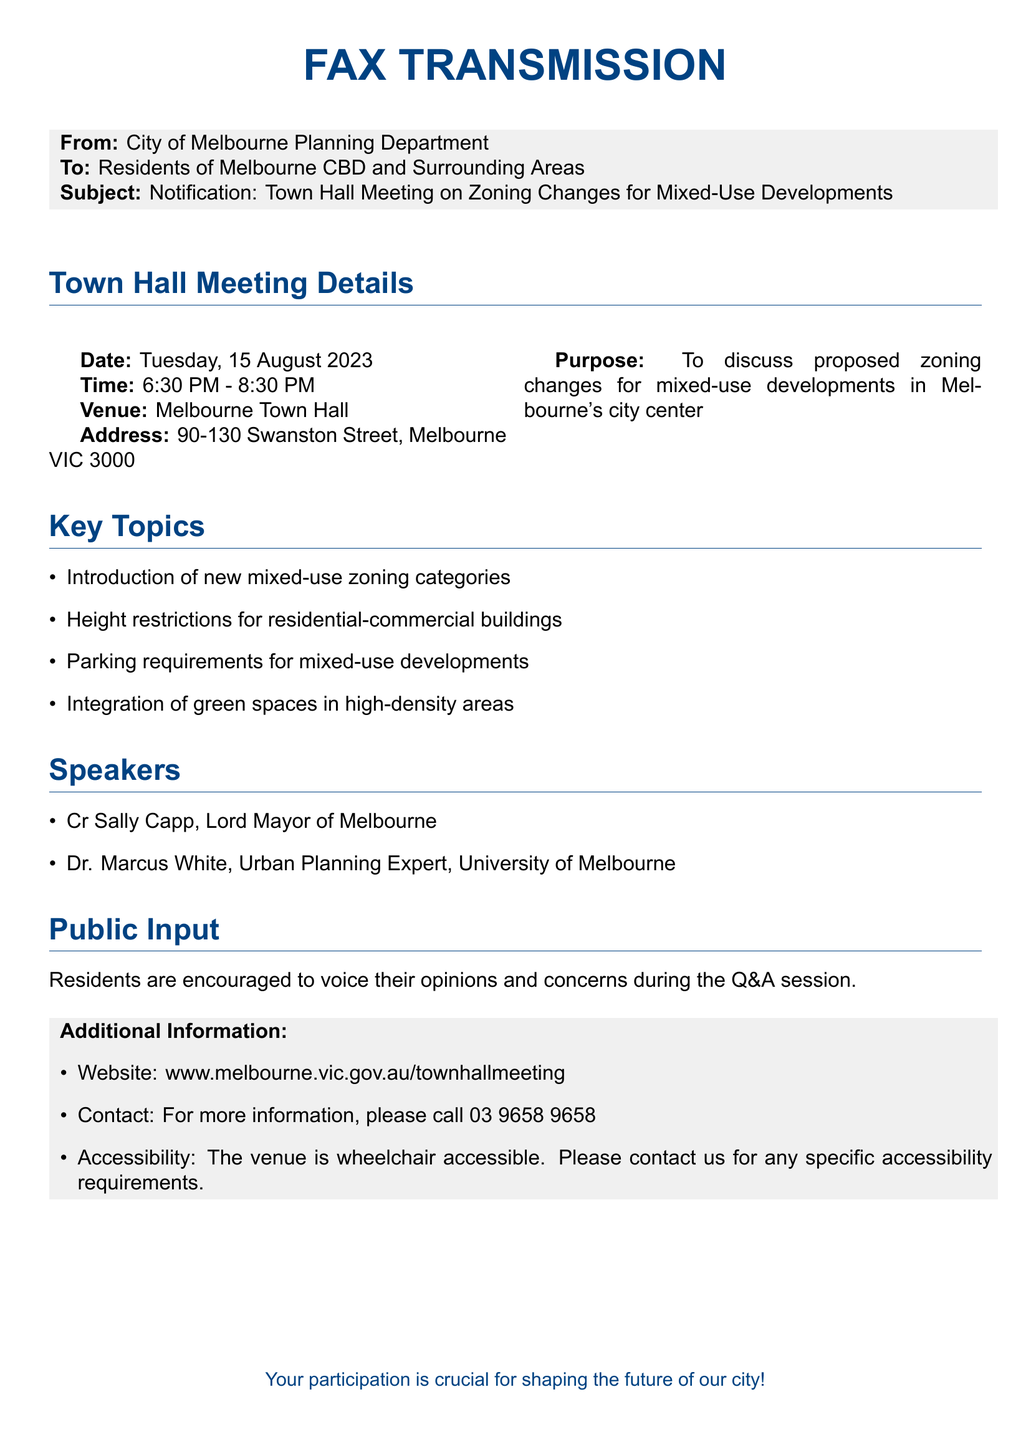what is the date of the town hall meeting? The date is explicitly stated in the meeting details section of the document.
Answer: Tuesday, 15 August 2023 what time does the meeting start? The start time is listed under the town hall meeting details.
Answer: 6:30 PM where is the meeting venue? The venue is clearly identified in the town hall meeting details.
Answer: Melbourne Town Hall who is the Lord Mayor of Melbourne? The name of the Lord Mayor is mentioned under the speakers section of the document.
Answer: Cr Sally Capp what is one of the key topics to be discussed? A list of key topics is provided, and one can be selected from that list.
Answer: Introduction of new mixed-use zoning categories how long does the meeting last? The duration is calculated from the start and end times mentioned in the document.
Answer: 2 hours what is the address of the venue? The address is specified in the meeting details section.
Answer: 90-130 Swanston Street, Melbourne VIC 3000 which department is sending the fax? The sender is explicitly mentioned at the beginning of the document.
Answer: City of Melbourne Planning Department how can residents get additional information? The method for getting additional information is described in the additional information section.
Answer: Call 03 9658 9658 